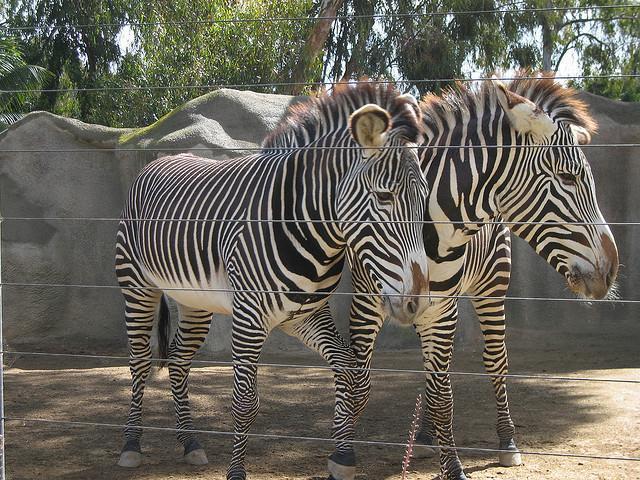How many zebras?
Give a very brief answer. 2. How many wires are holding the zebras in?
Give a very brief answer. 6. How many zebras are in the photo?
Give a very brief answer. 2. 